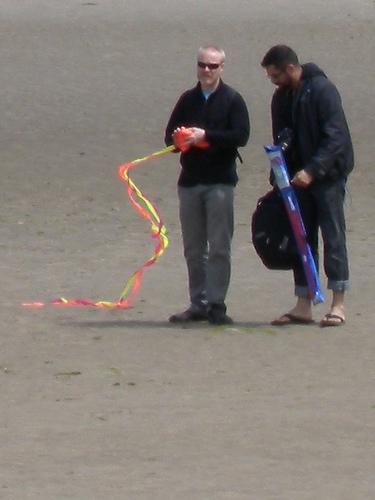How many people are in the picture?
Give a very brief answer. 2. 